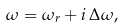Convert formula to latex. <formula><loc_0><loc_0><loc_500><loc_500>\omega = \omega _ { r } + i \, \Delta \omega ,</formula> 